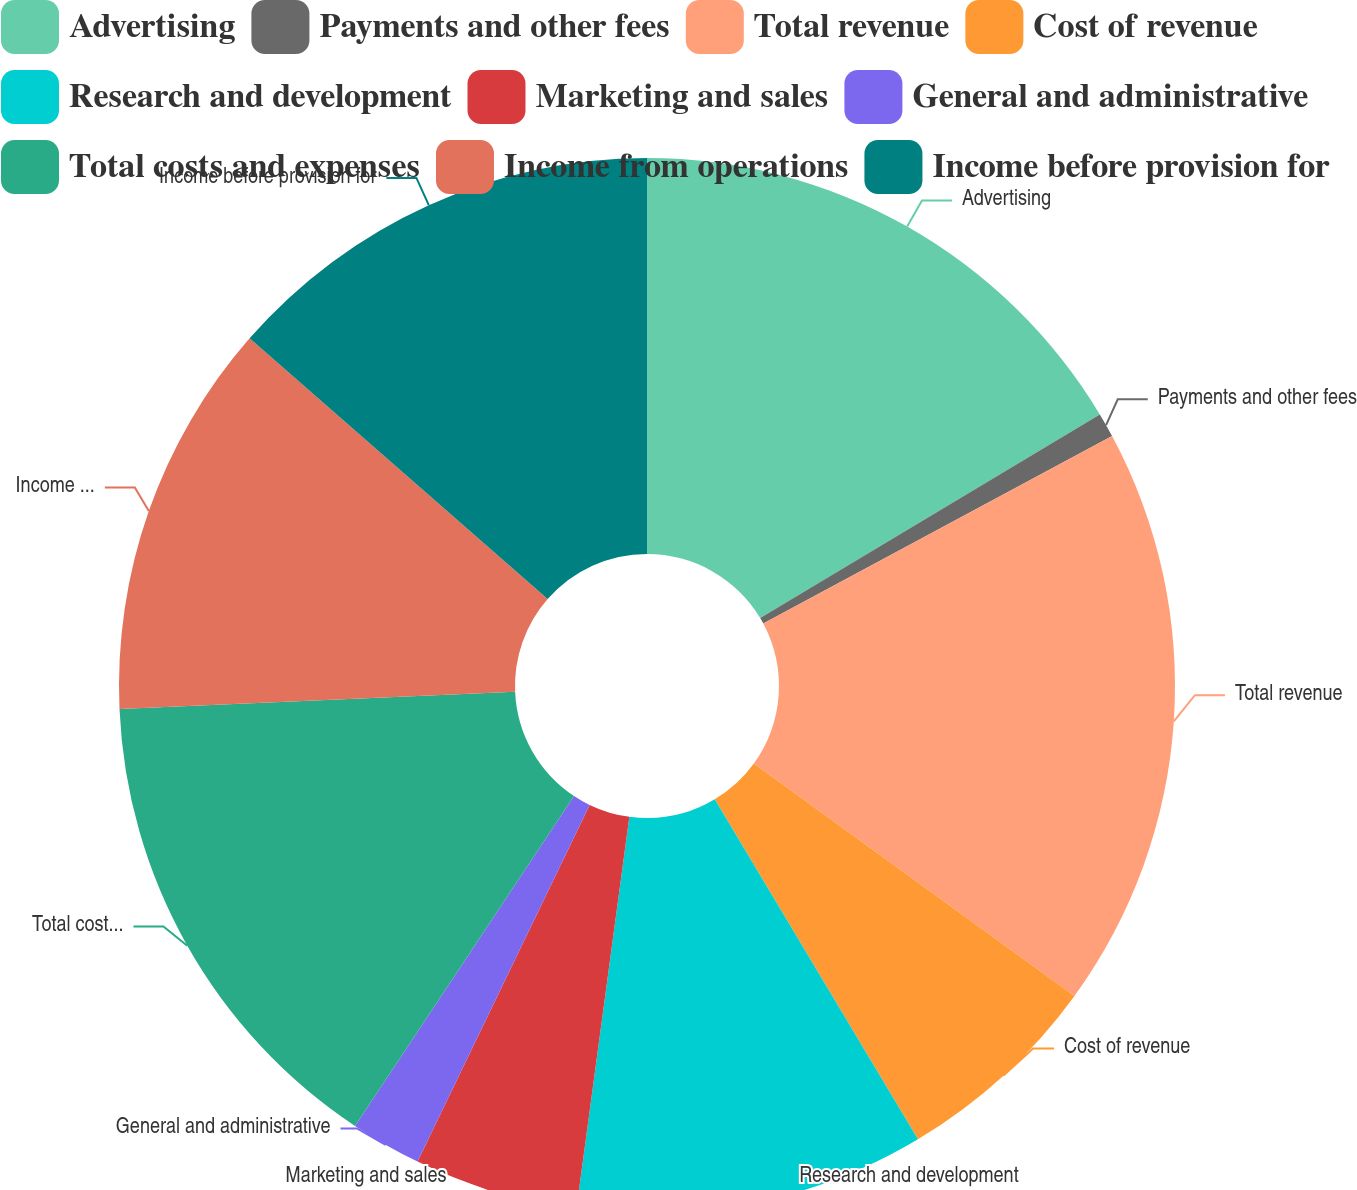<chart> <loc_0><loc_0><loc_500><loc_500><pie_chart><fcel>Advertising<fcel>Payments and other fees<fcel>Total revenue<fcel>Cost of revenue<fcel>Research and development<fcel>Marketing and sales<fcel>General and administrative<fcel>Total costs and expenses<fcel>Income from operations<fcel>Income before provision for<nl><fcel>16.4%<fcel>0.75%<fcel>17.83%<fcel>6.44%<fcel>10.71%<fcel>5.02%<fcel>2.17%<fcel>14.98%<fcel>12.13%<fcel>13.56%<nl></chart> 